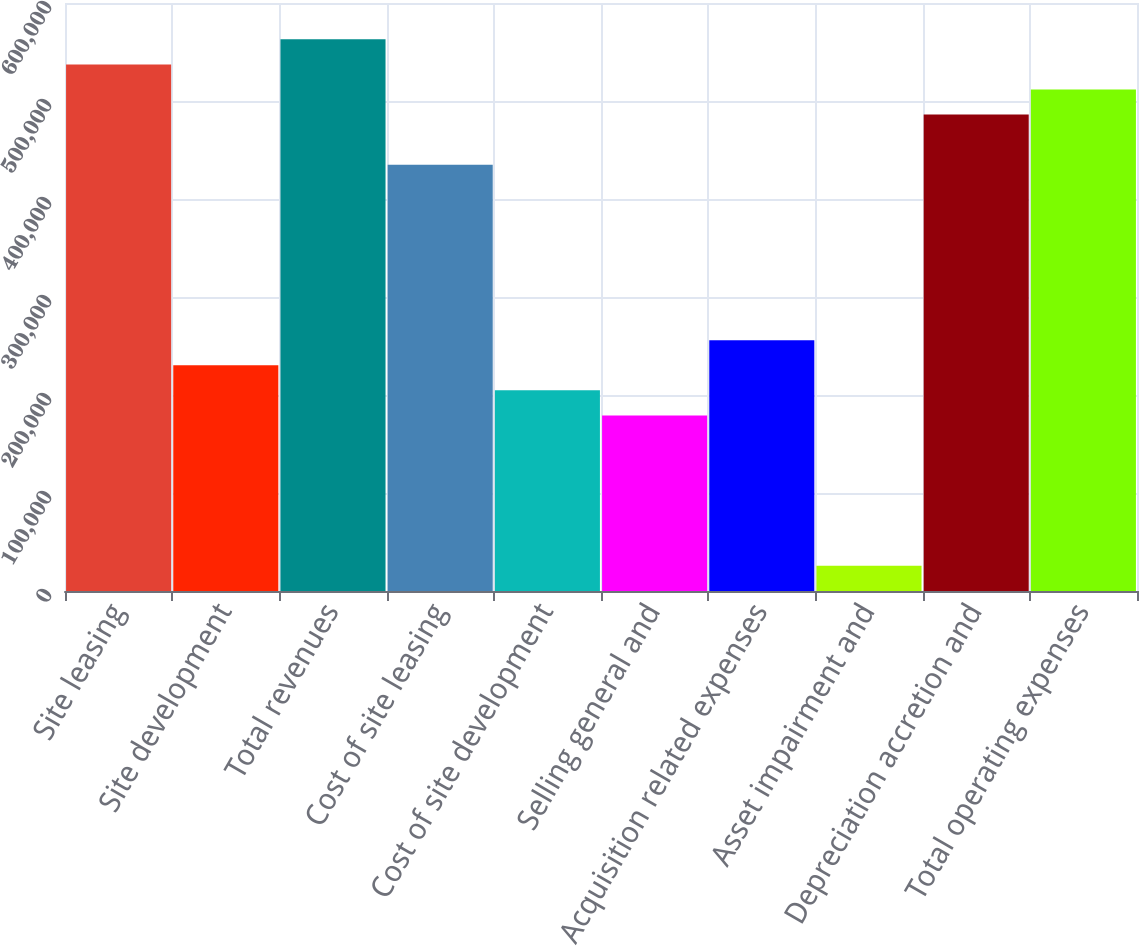<chart> <loc_0><loc_0><loc_500><loc_500><bar_chart><fcel>Site leasing<fcel>Site development<fcel>Total revenues<fcel>Cost of site leasing<fcel>Cost of site development<fcel>Selling general and<fcel>Acquisition related expenses<fcel>Asset impairment and<fcel>Depreciation accretion and<fcel>Total operating expenses<nl><fcel>537328<fcel>230331<fcel>562911<fcel>434996<fcel>204748<fcel>179165<fcel>255914<fcel>25666.1<fcel>486162<fcel>511745<nl></chart> 